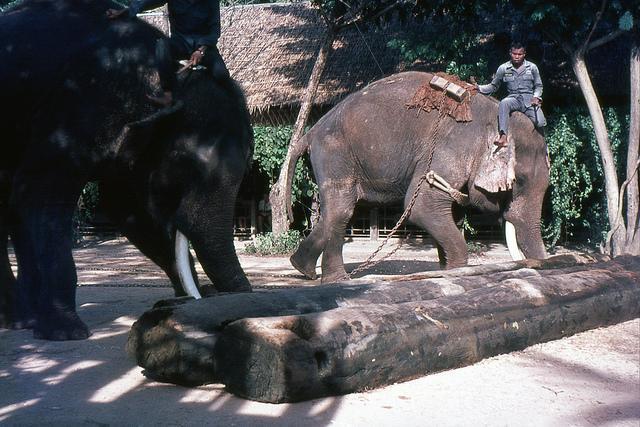What power will be used to move logs here?
Indicate the correct response by choosing from the four available options to answer the question.
Options: Elephant, tractor, man power, boats. Elephant. 